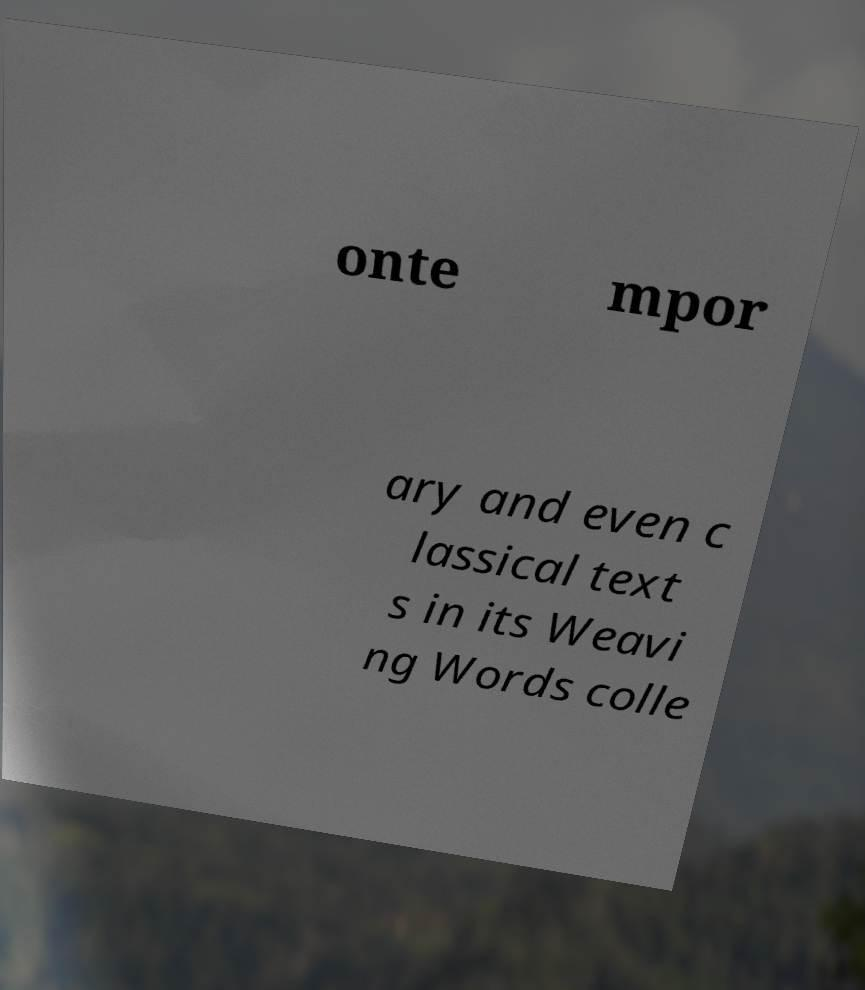There's text embedded in this image that I need extracted. Can you transcribe it verbatim? onte mpor ary and even c lassical text s in its Weavi ng Words colle 